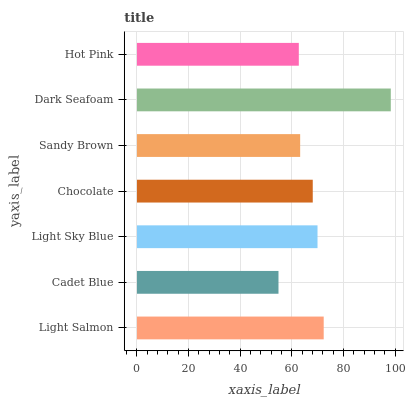Is Cadet Blue the minimum?
Answer yes or no. Yes. Is Dark Seafoam the maximum?
Answer yes or no. Yes. Is Light Sky Blue the minimum?
Answer yes or no. No. Is Light Sky Blue the maximum?
Answer yes or no. No. Is Light Sky Blue greater than Cadet Blue?
Answer yes or no. Yes. Is Cadet Blue less than Light Sky Blue?
Answer yes or no. Yes. Is Cadet Blue greater than Light Sky Blue?
Answer yes or no. No. Is Light Sky Blue less than Cadet Blue?
Answer yes or no. No. Is Chocolate the high median?
Answer yes or no. Yes. Is Chocolate the low median?
Answer yes or no. Yes. Is Hot Pink the high median?
Answer yes or no. No. Is Light Sky Blue the low median?
Answer yes or no. No. 